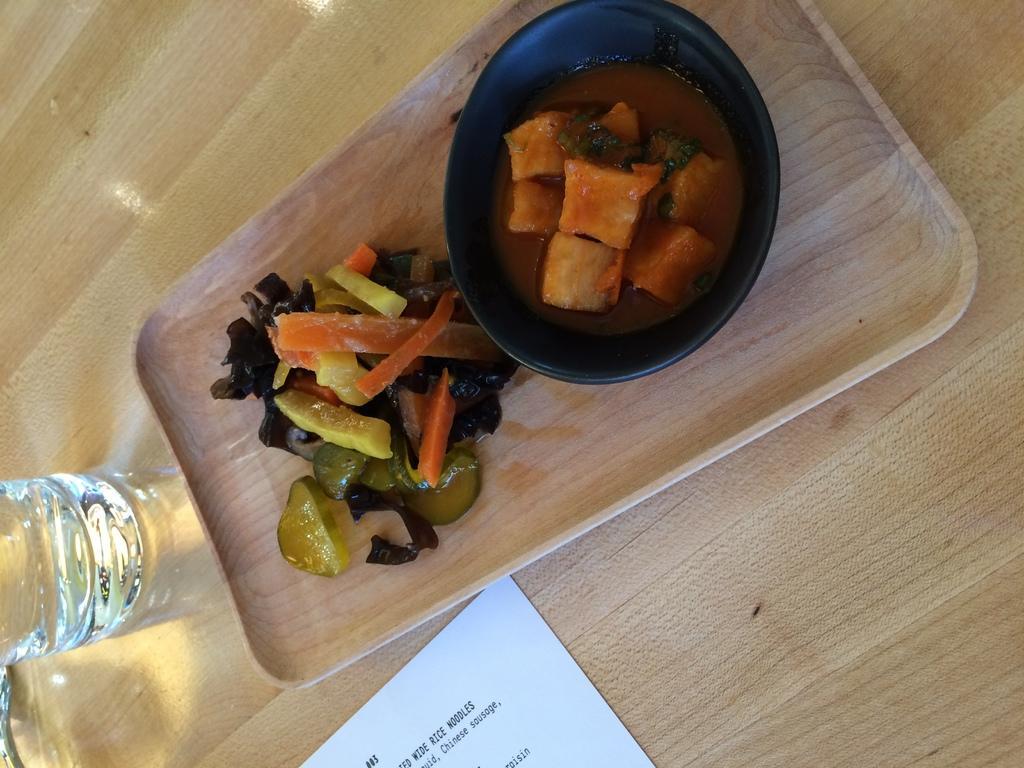How would you summarize this image in a sentence or two? In this image, we can see a table. In the middle of the table, we can see a plate with some food and a bowl, in the bowl, we can see some food item. In the middle of the table, we can see one edge of a paper with some text written on it. On the left side of the table, we can see a water glass. 